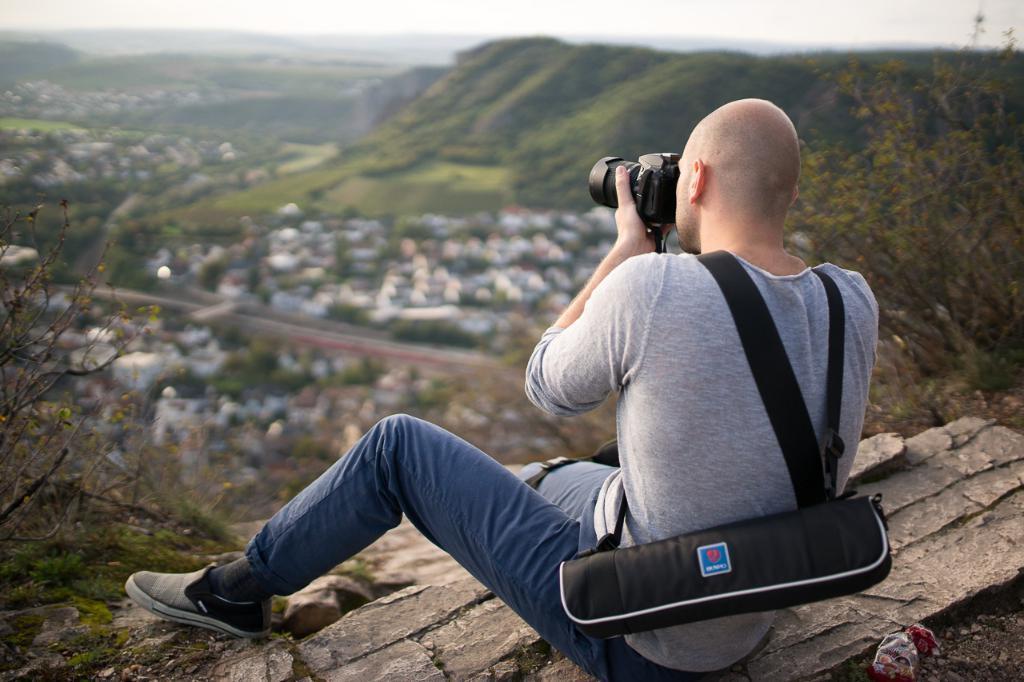In one or two sentences, can you explain what this image depicts? In this picture man is sitting on the ground holding a camera and clicking the image. He is wearing a backpack of black in colour. At the right side there is a plant. In the front there are grass, mountains. 